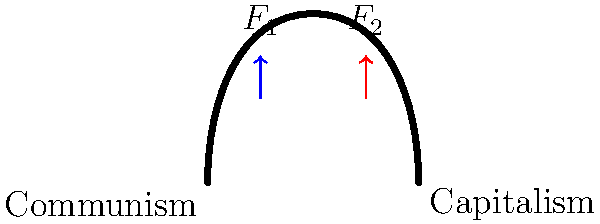In the sculpture representing the transition from communism to capitalism, two forces $F_1$ and $F_2$ are applied as shown. If $F_1 = 500\text{ N}$ and the total upward force on the sculpture is $800\text{ N}$, what is the magnitude of $F_2$? To solve this problem, we'll follow these steps:

1. Identify the given information:
   - $F_1 = 500\text{ N}$
   - Total upward force = $800\text{ N}$

2. Set up an equation for the total upward force:
   Total upward force = $F_1 + F_2$

3. Substitute the known values:
   $800\text{ N} = 500\text{ N} + F_2$

4. Solve for $F_2$:
   $F_2 = 800\text{ N} - 500\text{ N}$
   $F_2 = 300\text{ N}$

5. Check the result:
   $500\text{ N} + 300\text{ N} = 800\text{ N}$ (Total upward force)

Therefore, the magnitude of $F_2$ is 300 N.
Answer: $300\text{ N}$ 